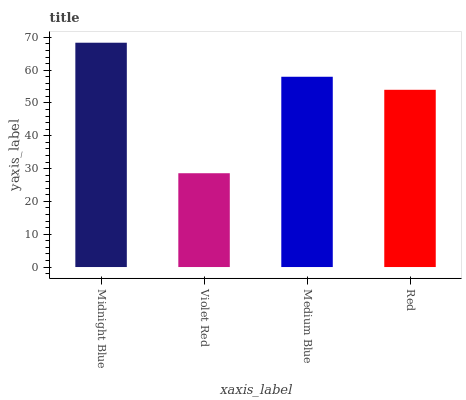Is Violet Red the minimum?
Answer yes or no. Yes. Is Midnight Blue the maximum?
Answer yes or no. Yes. Is Medium Blue the minimum?
Answer yes or no. No. Is Medium Blue the maximum?
Answer yes or no. No. Is Medium Blue greater than Violet Red?
Answer yes or no. Yes. Is Violet Red less than Medium Blue?
Answer yes or no. Yes. Is Violet Red greater than Medium Blue?
Answer yes or no. No. Is Medium Blue less than Violet Red?
Answer yes or no. No. Is Medium Blue the high median?
Answer yes or no. Yes. Is Red the low median?
Answer yes or no. Yes. Is Midnight Blue the high median?
Answer yes or no. No. Is Midnight Blue the low median?
Answer yes or no. No. 